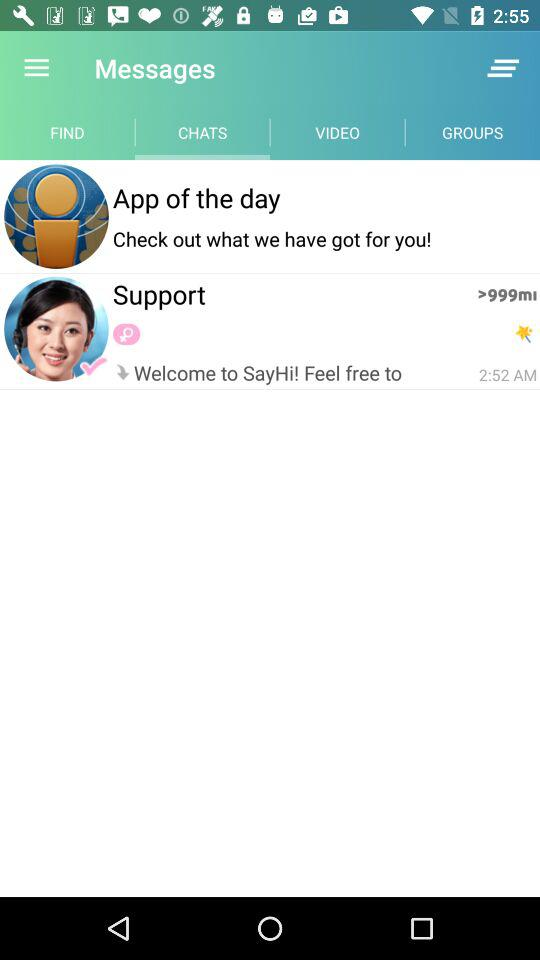What message has come from "App of the day"? The message is "Check out what we have got for you!". 